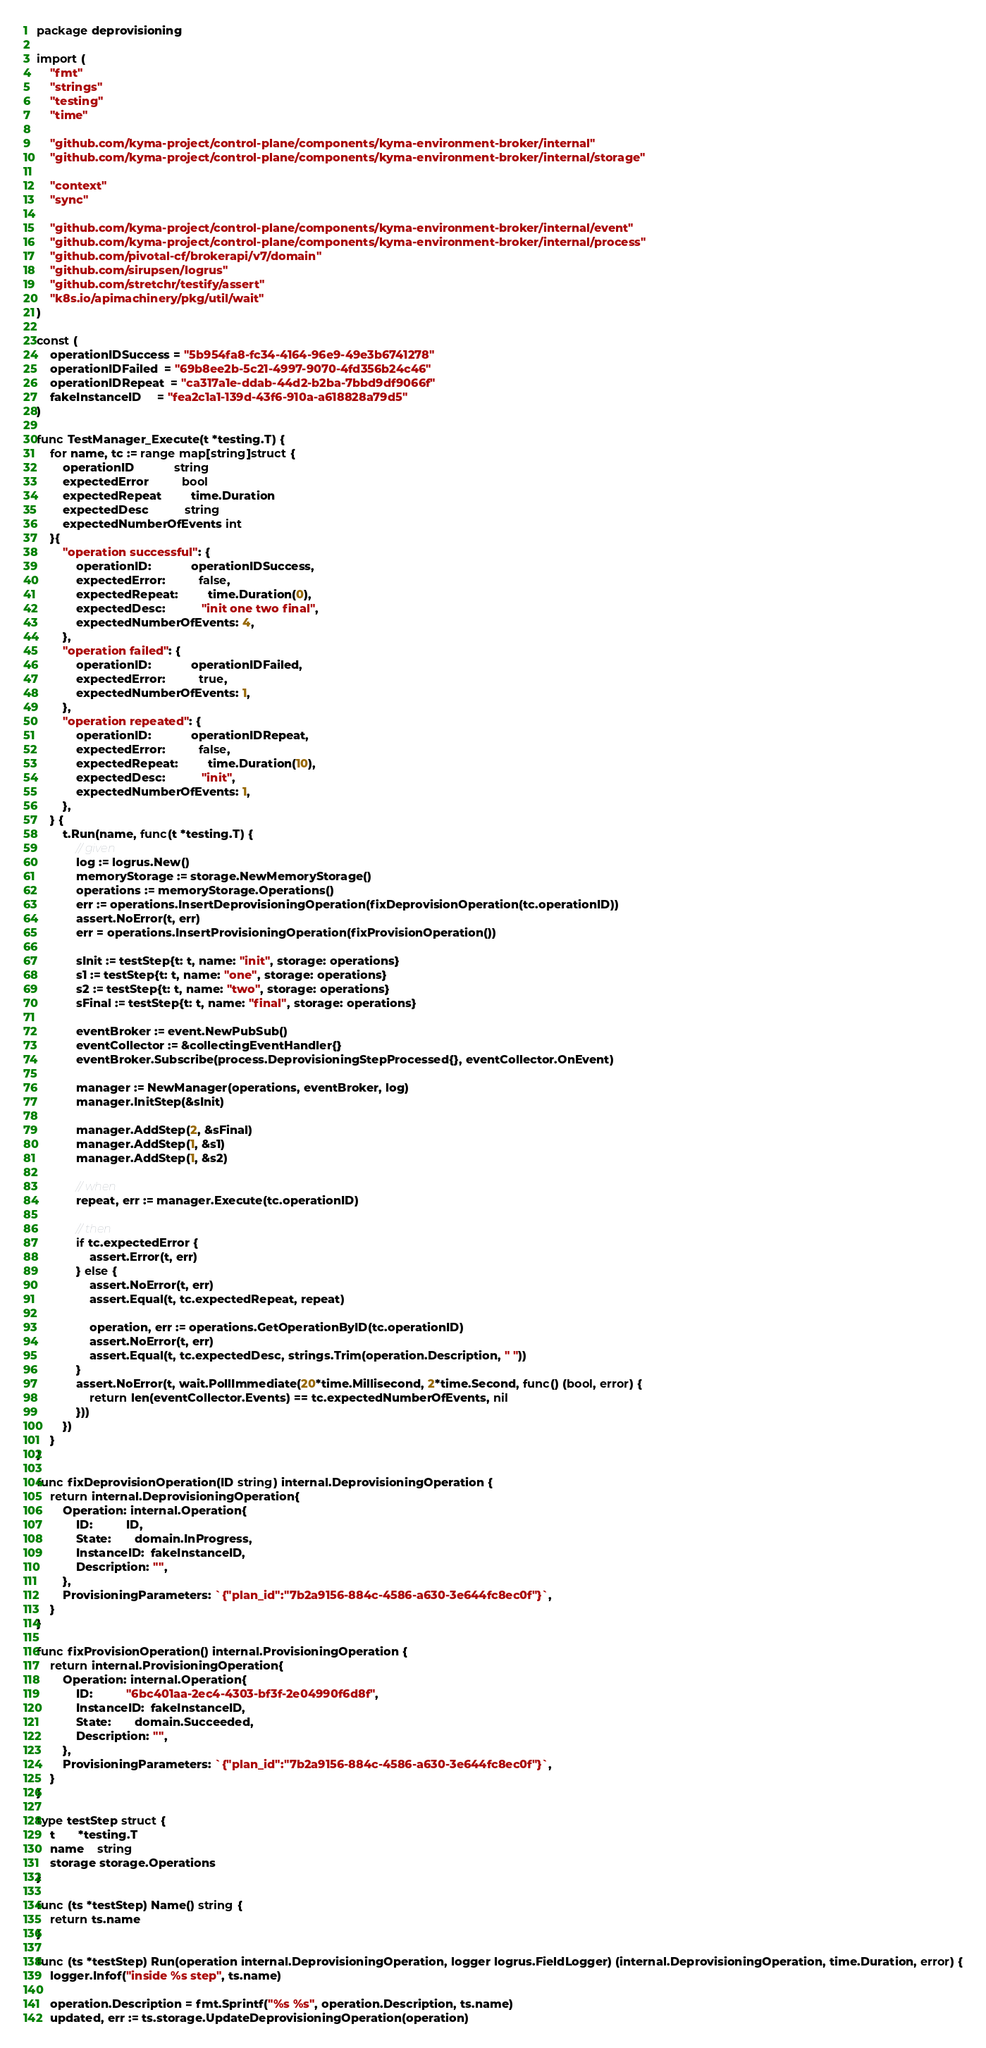<code> <loc_0><loc_0><loc_500><loc_500><_Go_>package deprovisioning

import (
	"fmt"
	"strings"
	"testing"
	"time"

	"github.com/kyma-project/control-plane/components/kyma-environment-broker/internal"
	"github.com/kyma-project/control-plane/components/kyma-environment-broker/internal/storage"

	"context"
	"sync"

	"github.com/kyma-project/control-plane/components/kyma-environment-broker/internal/event"
	"github.com/kyma-project/control-plane/components/kyma-environment-broker/internal/process"
	"github.com/pivotal-cf/brokerapi/v7/domain"
	"github.com/sirupsen/logrus"
	"github.com/stretchr/testify/assert"
	"k8s.io/apimachinery/pkg/util/wait"
)

const (
	operationIDSuccess = "5b954fa8-fc34-4164-96e9-49e3b6741278"
	operationIDFailed  = "69b8ee2b-5c21-4997-9070-4fd356b24c46"
	operationIDRepeat  = "ca317a1e-ddab-44d2-b2ba-7bbd9df9066f"
	fakeInstanceID     = "fea2c1a1-139d-43f6-910a-a618828a79d5"
)

func TestManager_Execute(t *testing.T) {
	for name, tc := range map[string]struct {
		operationID            string
		expectedError          bool
		expectedRepeat         time.Duration
		expectedDesc           string
		expectedNumberOfEvents int
	}{
		"operation successful": {
			operationID:            operationIDSuccess,
			expectedError:          false,
			expectedRepeat:         time.Duration(0),
			expectedDesc:           "init one two final",
			expectedNumberOfEvents: 4,
		},
		"operation failed": {
			operationID:            operationIDFailed,
			expectedError:          true,
			expectedNumberOfEvents: 1,
		},
		"operation repeated": {
			operationID:            operationIDRepeat,
			expectedError:          false,
			expectedRepeat:         time.Duration(10),
			expectedDesc:           "init",
			expectedNumberOfEvents: 1,
		},
	} {
		t.Run(name, func(t *testing.T) {
			// given
			log := logrus.New()
			memoryStorage := storage.NewMemoryStorage()
			operations := memoryStorage.Operations()
			err := operations.InsertDeprovisioningOperation(fixDeprovisionOperation(tc.operationID))
			assert.NoError(t, err)
			err = operations.InsertProvisioningOperation(fixProvisionOperation())

			sInit := testStep{t: t, name: "init", storage: operations}
			s1 := testStep{t: t, name: "one", storage: operations}
			s2 := testStep{t: t, name: "two", storage: operations}
			sFinal := testStep{t: t, name: "final", storage: operations}

			eventBroker := event.NewPubSub()
			eventCollector := &collectingEventHandler{}
			eventBroker.Subscribe(process.DeprovisioningStepProcessed{}, eventCollector.OnEvent)

			manager := NewManager(operations, eventBroker, log)
			manager.InitStep(&sInit)

			manager.AddStep(2, &sFinal)
			manager.AddStep(1, &s1)
			manager.AddStep(1, &s2)

			// when
			repeat, err := manager.Execute(tc.operationID)

			// then
			if tc.expectedError {
				assert.Error(t, err)
			} else {
				assert.NoError(t, err)
				assert.Equal(t, tc.expectedRepeat, repeat)

				operation, err := operations.GetOperationByID(tc.operationID)
				assert.NoError(t, err)
				assert.Equal(t, tc.expectedDesc, strings.Trim(operation.Description, " "))
			}
			assert.NoError(t, wait.PollImmediate(20*time.Millisecond, 2*time.Second, func() (bool, error) {
				return len(eventCollector.Events) == tc.expectedNumberOfEvents, nil
			}))
		})
	}
}

func fixDeprovisionOperation(ID string) internal.DeprovisioningOperation {
	return internal.DeprovisioningOperation{
		Operation: internal.Operation{
			ID:          ID,
			State:       domain.InProgress,
			InstanceID:  fakeInstanceID,
			Description: "",
		},
		ProvisioningParameters: `{"plan_id":"7b2a9156-884c-4586-a630-3e644fc8ec0f"}`,
	}
}

func fixProvisionOperation() internal.ProvisioningOperation {
	return internal.ProvisioningOperation{
		Operation: internal.Operation{
			ID:          "6bc401aa-2ec4-4303-bf3f-2e04990f6d8f",
			InstanceID:  fakeInstanceID,
			State:       domain.Succeeded,
			Description: "",
		},
		ProvisioningParameters: `{"plan_id":"7b2a9156-884c-4586-a630-3e644fc8ec0f"}`,
	}
}

type testStep struct {
	t       *testing.T
	name    string
	storage storage.Operations
}

func (ts *testStep) Name() string {
	return ts.name
}

func (ts *testStep) Run(operation internal.DeprovisioningOperation, logger logrus.FieldLogger) (internal.DeprovisioningOperation, time.Duration, error) {
	logger.Infof("inside %s step", ts.name)

	operation.Description = fmt.Sprintf("%s %s", operation.Description, ts.name)
	updated, err := ts.storage.UpdateDeprovisioningOperation(operation)</code> 